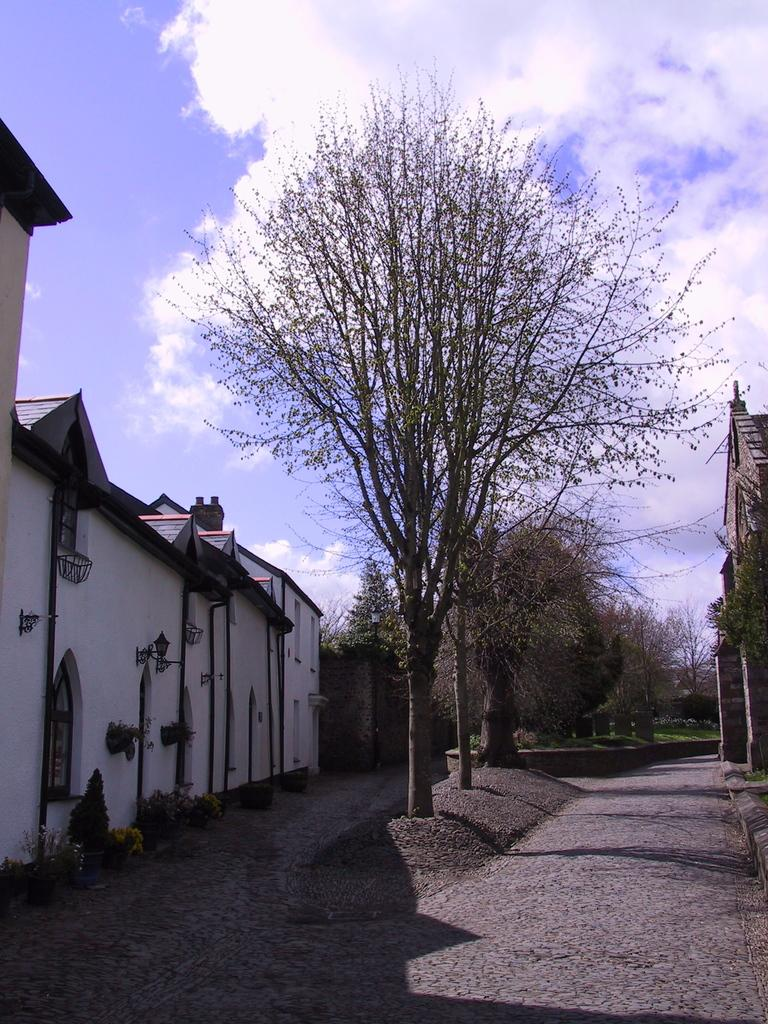What type of vegetation can be seen in the image? There are trees in the image. What structure is located on the left side of the image? There is a building on the left side of the image. What is visible in the background of the image? The sky is visible in the background of the image. What type of party is happening in the image? There is no party present in the image. Who is the porter in the image? There is no porter present in the image. Is there a bomb visible in the image? There is no bomb present in the image. 